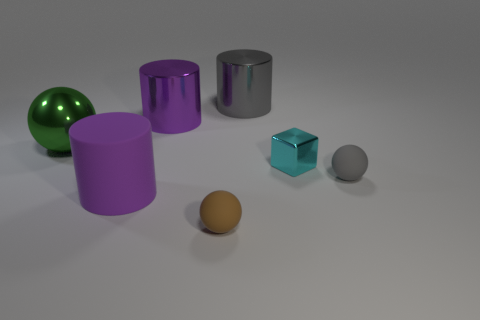Add 1 small brown matte spheres. How many objects exist? 8 Subtract all spheres. How many objects are left? 4 Add 7 cyan metallic blocks. How many cyan metallic blocks are left? 8 Add 1 tiny yellow shiny cylinders. How many tiny yellow shiny cylinders exist? 1 Subtract 1 brown balls. How many objects are left? 6 Subtract all big purple cylinders. Subtract all big brown spheres. How many objects are left? 5 